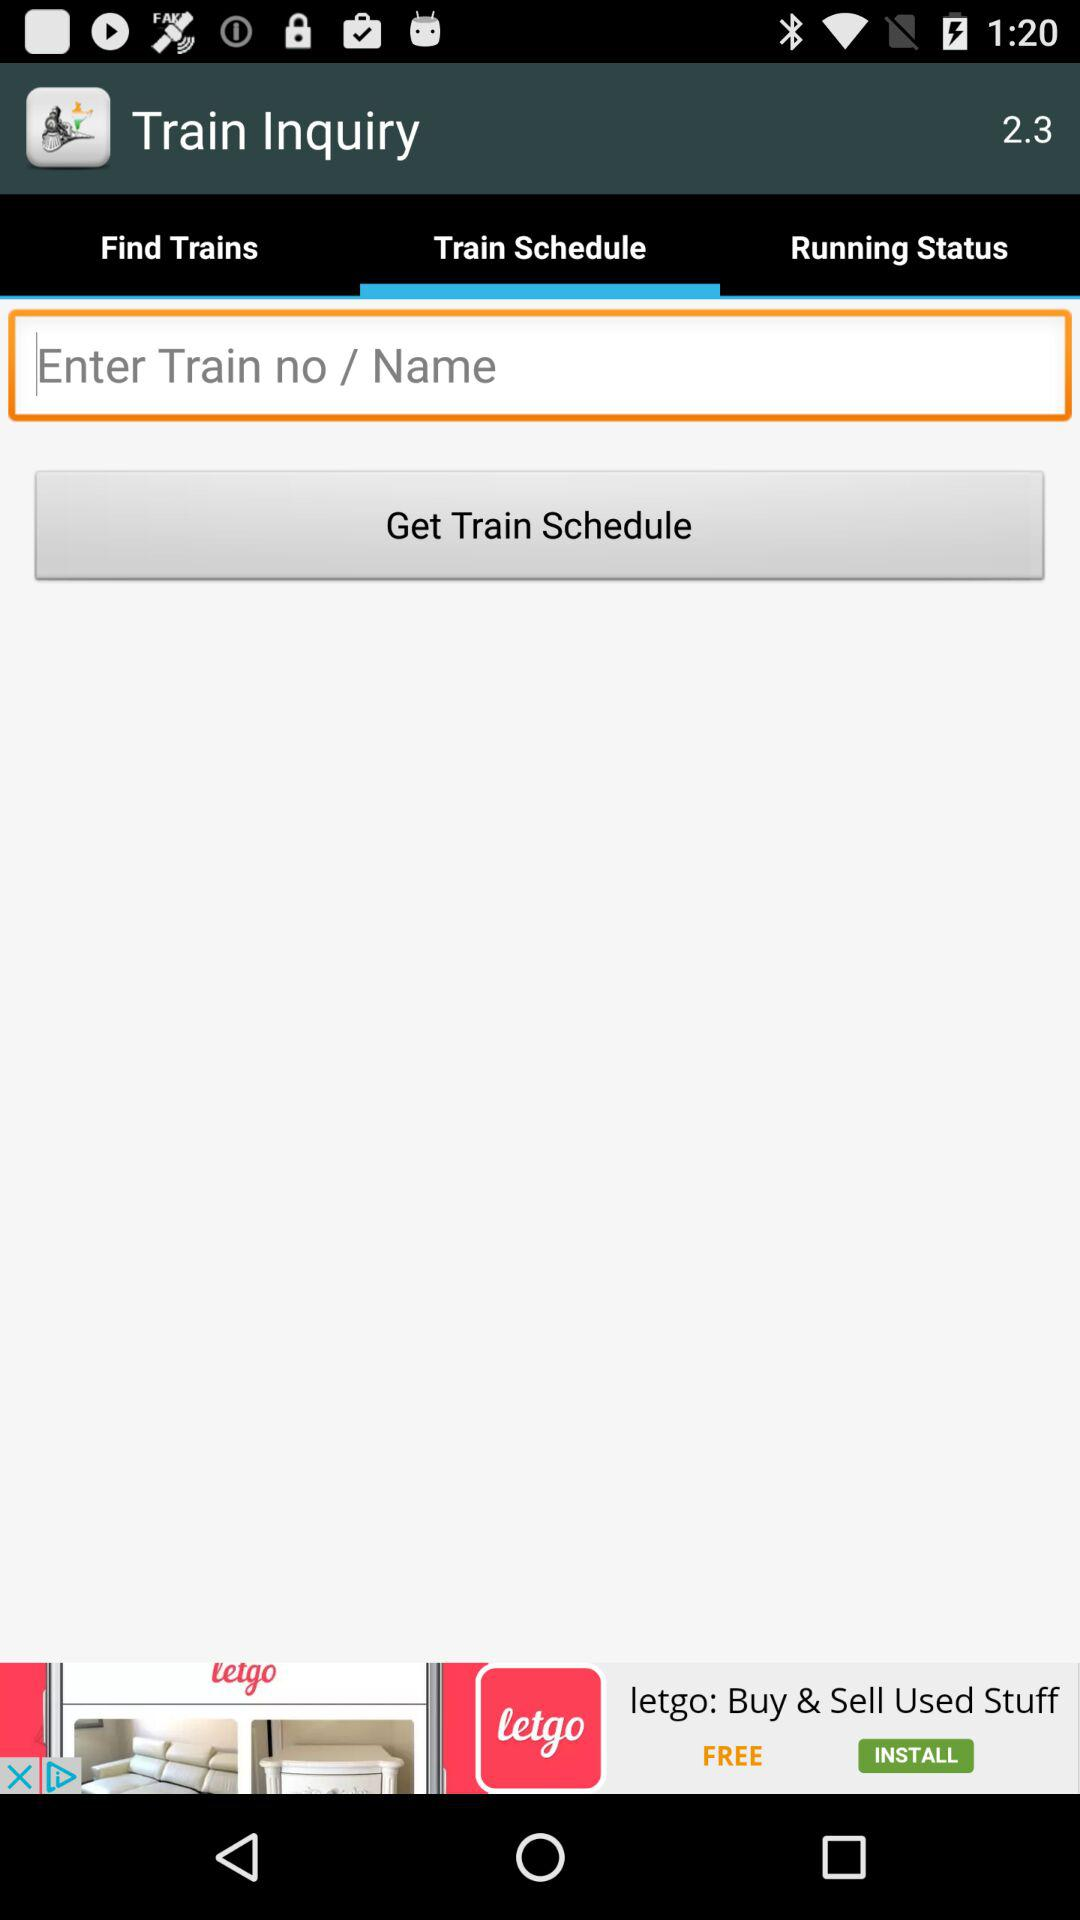What is the version of the "Train Inquiry" application? The version is 2.3. 